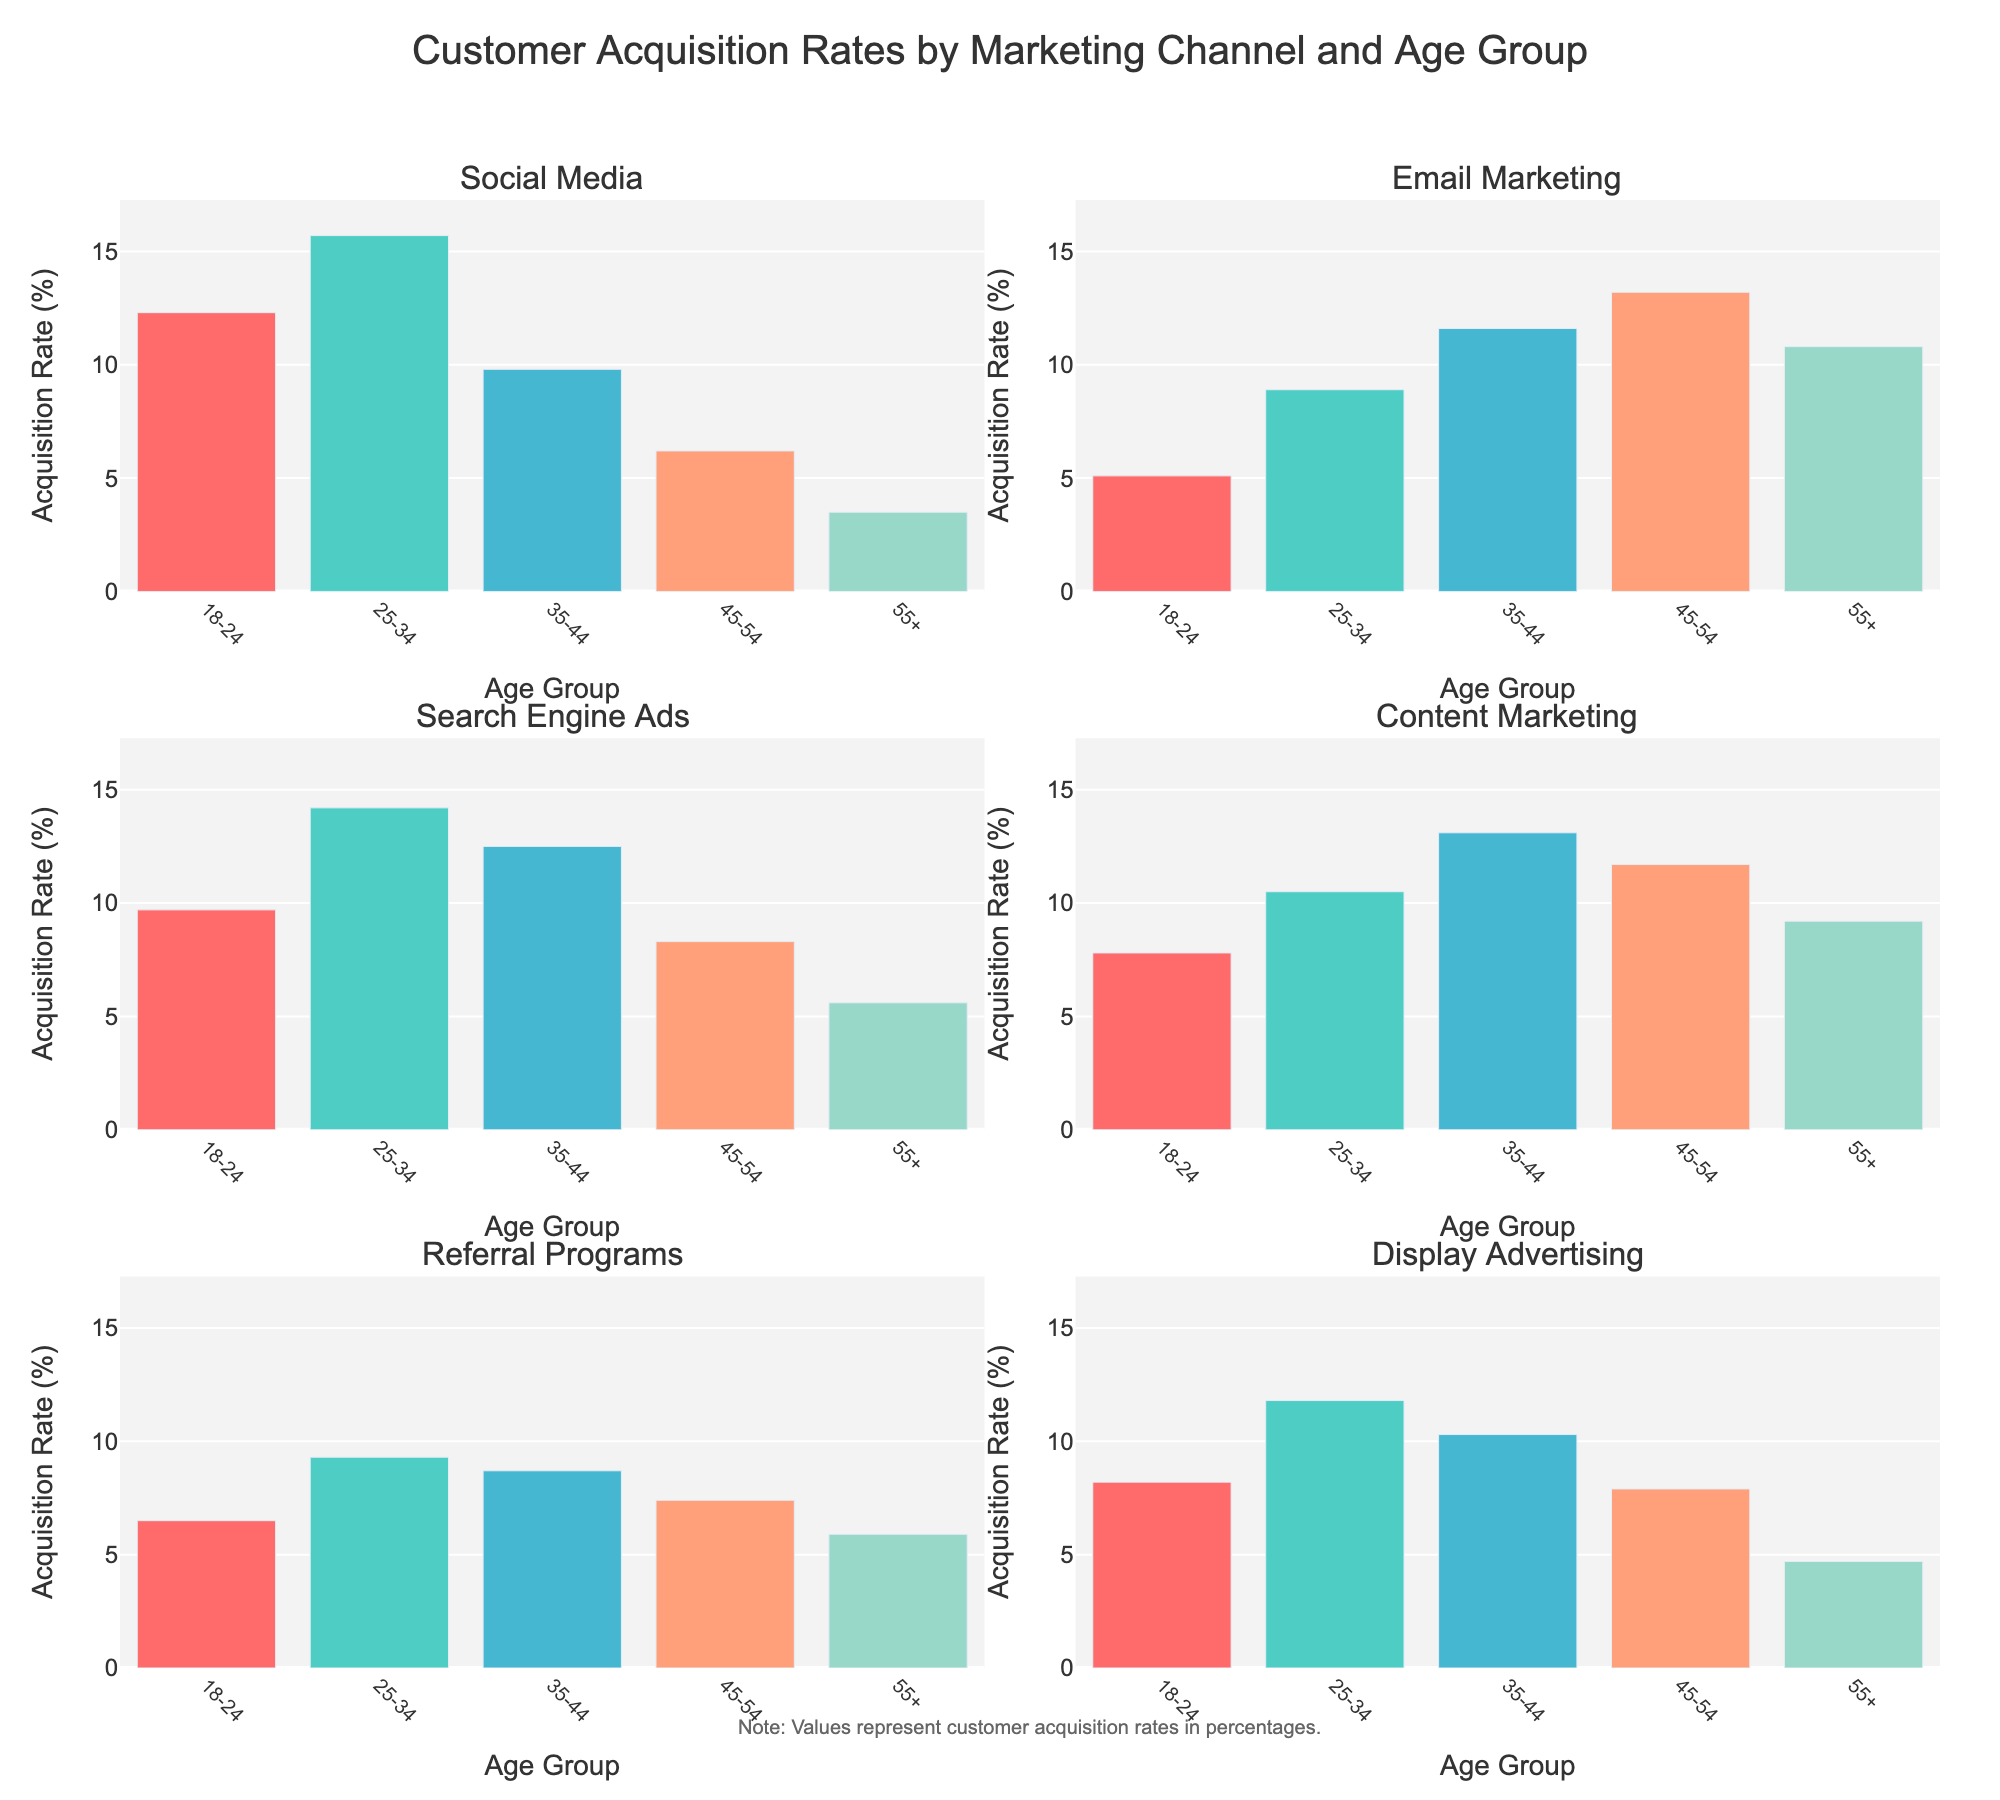Which marketing channel has the highest acquisition rate for the 18-24 age group? Look at the bar heights for the 18-24 age group across all six subplots. The highest bar corresponds to the "Social Media" channel.
Answer: Social Media Which age group has the highest acquisition rate for Content Marketing? Look at the bar heights in the Content Marketing subplot. The highest bar corresponds to the 35-44 age group.
Answer: 35-44 What is the total acquisition rate for Email Marketing across all age groups? Add the bar heights (acquisition rates) for all age groups in the Email Marketing subplot: 5.1 + 8.9 + 11.6 + 13.2 + 10.8 = 49.6.
Answer: 49.6 Which marketing channel has the lowest acquisition rate for the 55+ age group? Look at the bar heights for the 55+ age group across all six subplots. The smallest bar corresponds to the "Social Media" channel.
Answer: Social Media How do the acquisition rates for the 25-34 age group compare between Search Engine Ads and Display Advertising? Compare the bar heights for the 25-34 age group in the Search Engine Ads and Display Advertising subplots. Search Engine Ads have a higher rate (14.2) than Display Advertising (11.8).
Answer: Search Engine Ads > Display Advertising What is the difference in acquisition rates between the highest and lowest age groups for Referral Programs? Find the highest and lowest bars in the Referral Programs subplot. Subtract the lowest rate (5.9 for 55+) from the highest rate (9.3 for 25-34): 9.3 - 5.9 = 3.4.
Answer: 3.4 Which marketing channel among those listed shows the least variation in acquisition rates across different age groups? Look at the bar heights across all age groups for each channel. Referral Programs show relatively consistent bar heights, indicating the least variation.
Answer: Referral Programs What is the average acquisition rate for the age group 35-44 across all marketing channels? Add the bar heights for the 35-44 age group across all subplots: 9.8 + 11.6 + 12.5 + 13.1 + 8.7 + 10.3, then divide by the number of channels (6): (9.8 + 11.6 + 12.5 + 13.1 + 8.7 + 10.3) / 6 = 66 / 6 = 11.
Answer: 11 What is the total acquisition rate for Social Media and Email Marketing combined across the 18-24 age group? Add the bar heights for the 18-24 age group from both Social Media and Email Marketing subplots: 12.3 (Social Media) + 5.1 (Email Marketing) = 17.4.
Answer: 17.4 